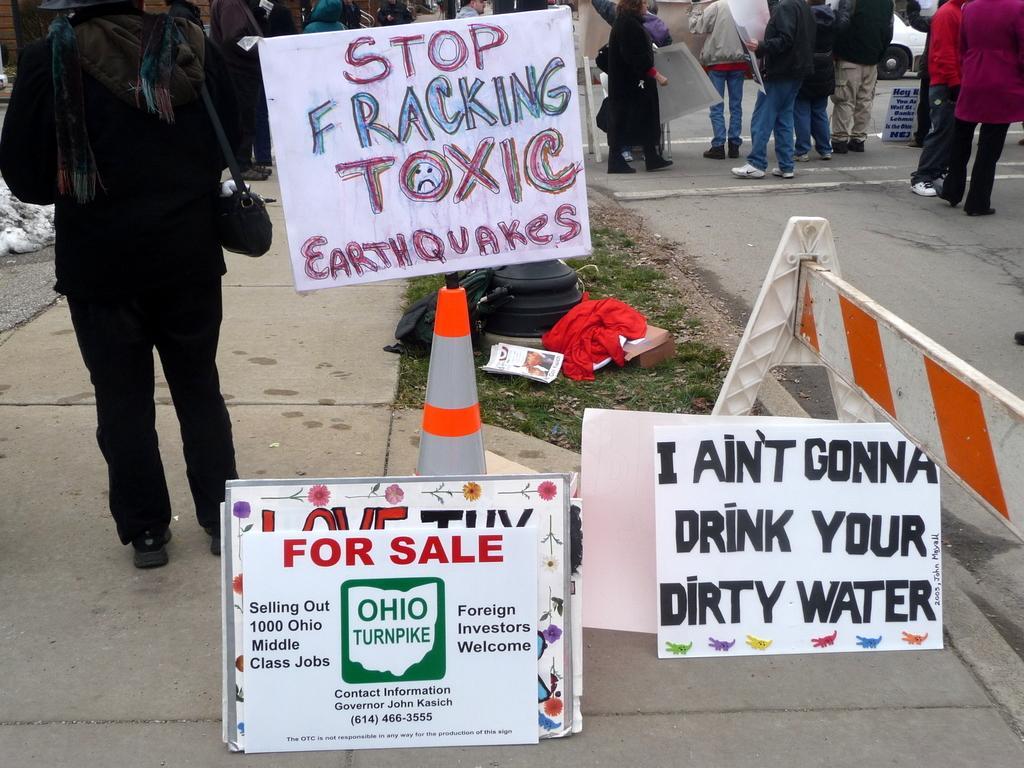Could you give a brief overview of what you see in this image? There are posters present the bottom of this image. We can see people standing in the background. 